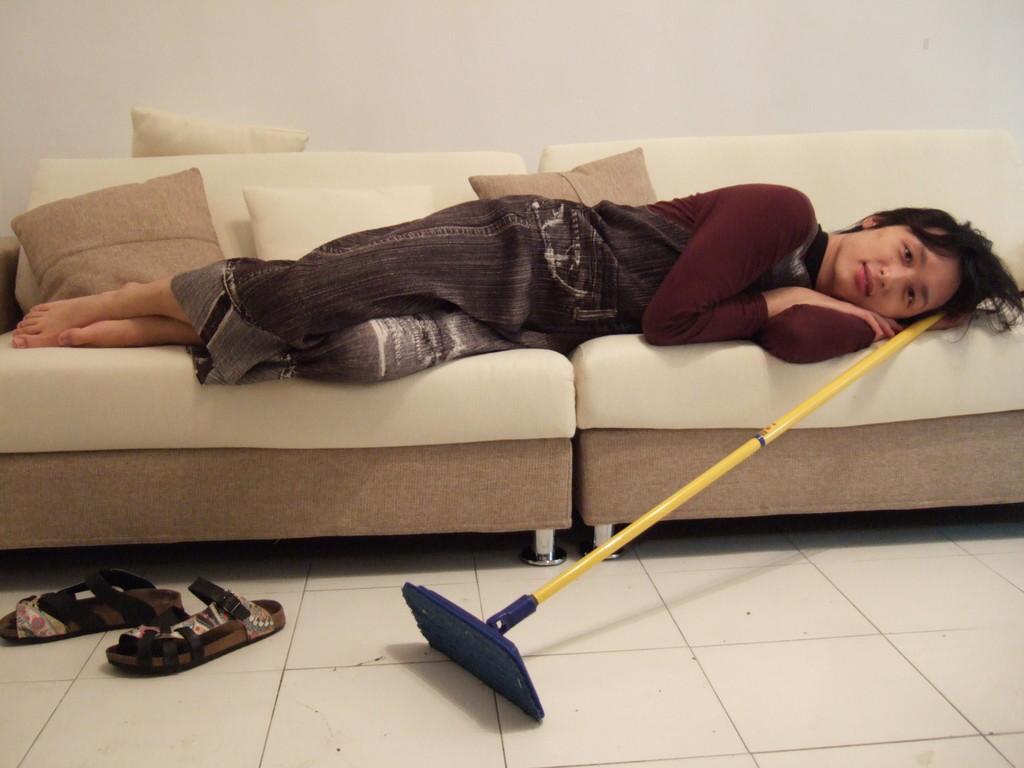Could you give a brief overview of what you see in this image? I can see this image with person is lying on a couch and there is a footwear and an object on the floor. On the couch we have few cushions on it. 